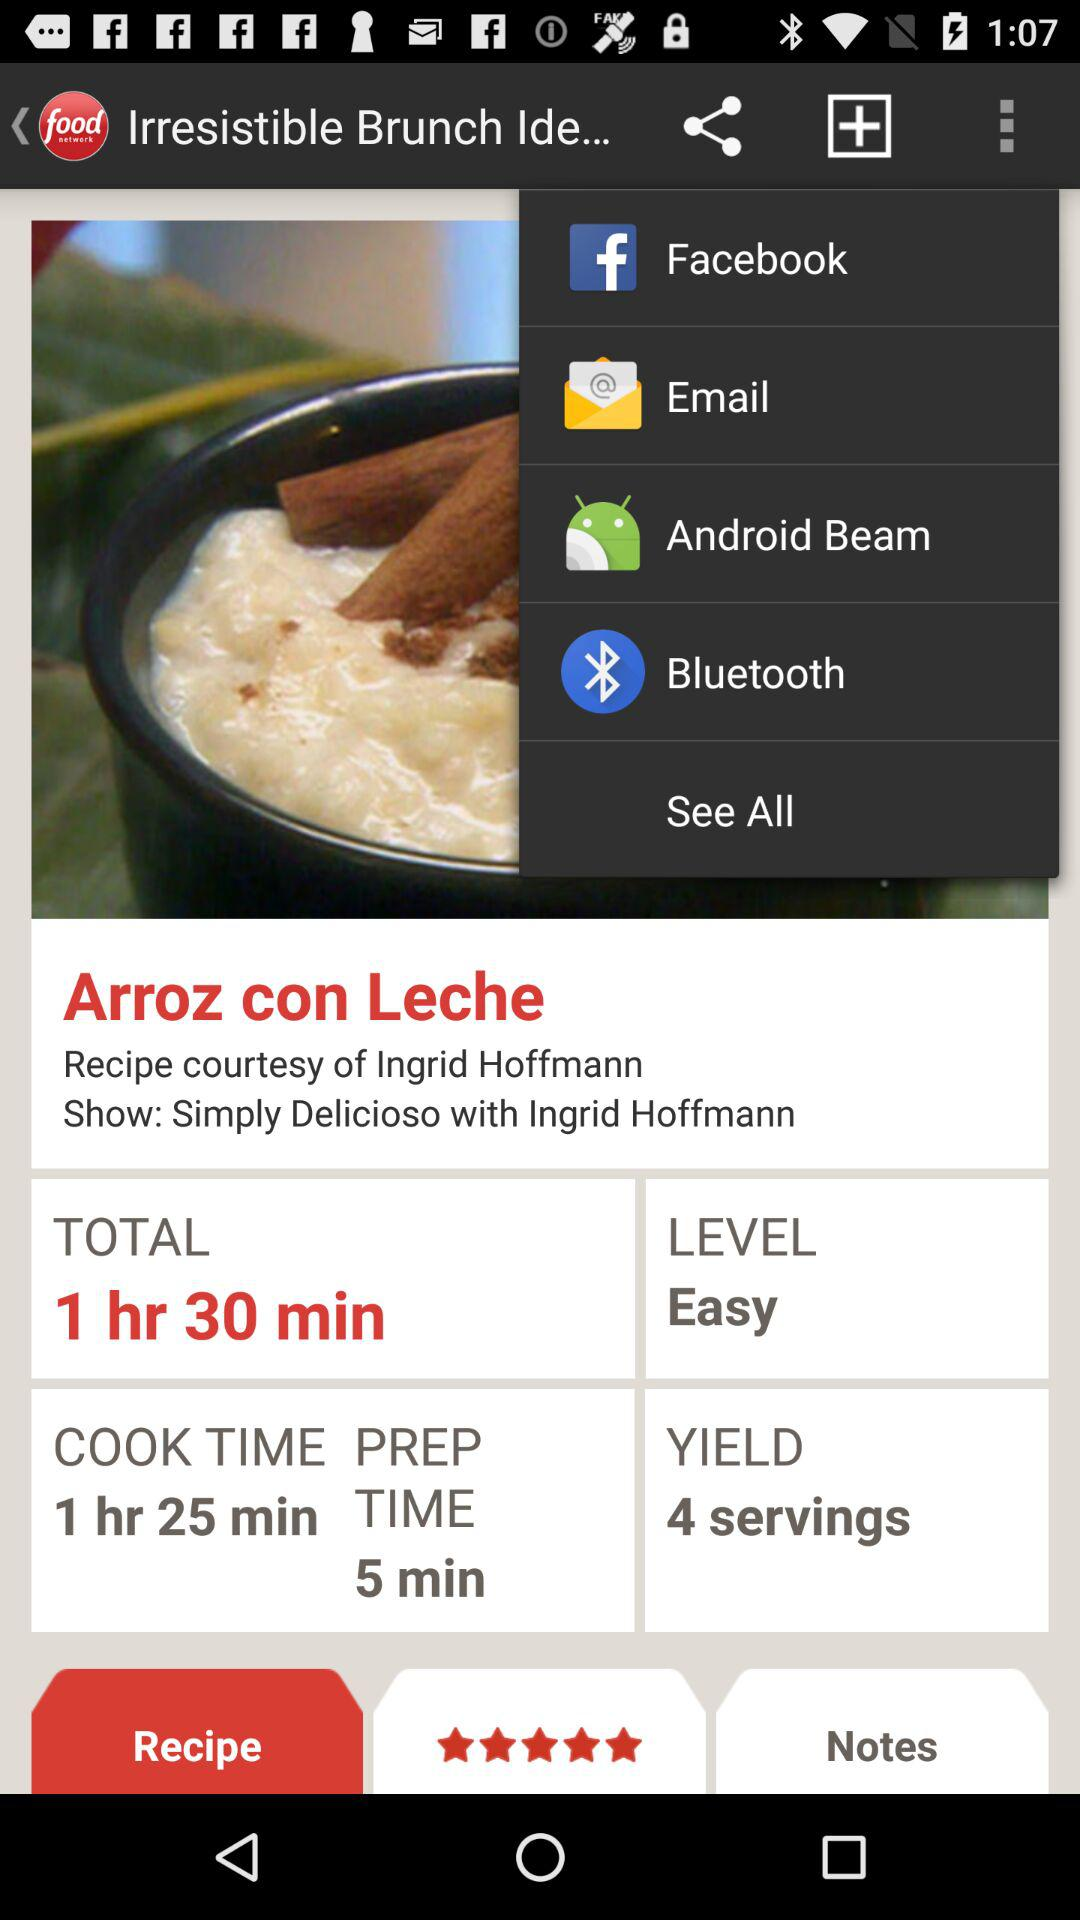What are the ratings? The rating is 5 stars. 